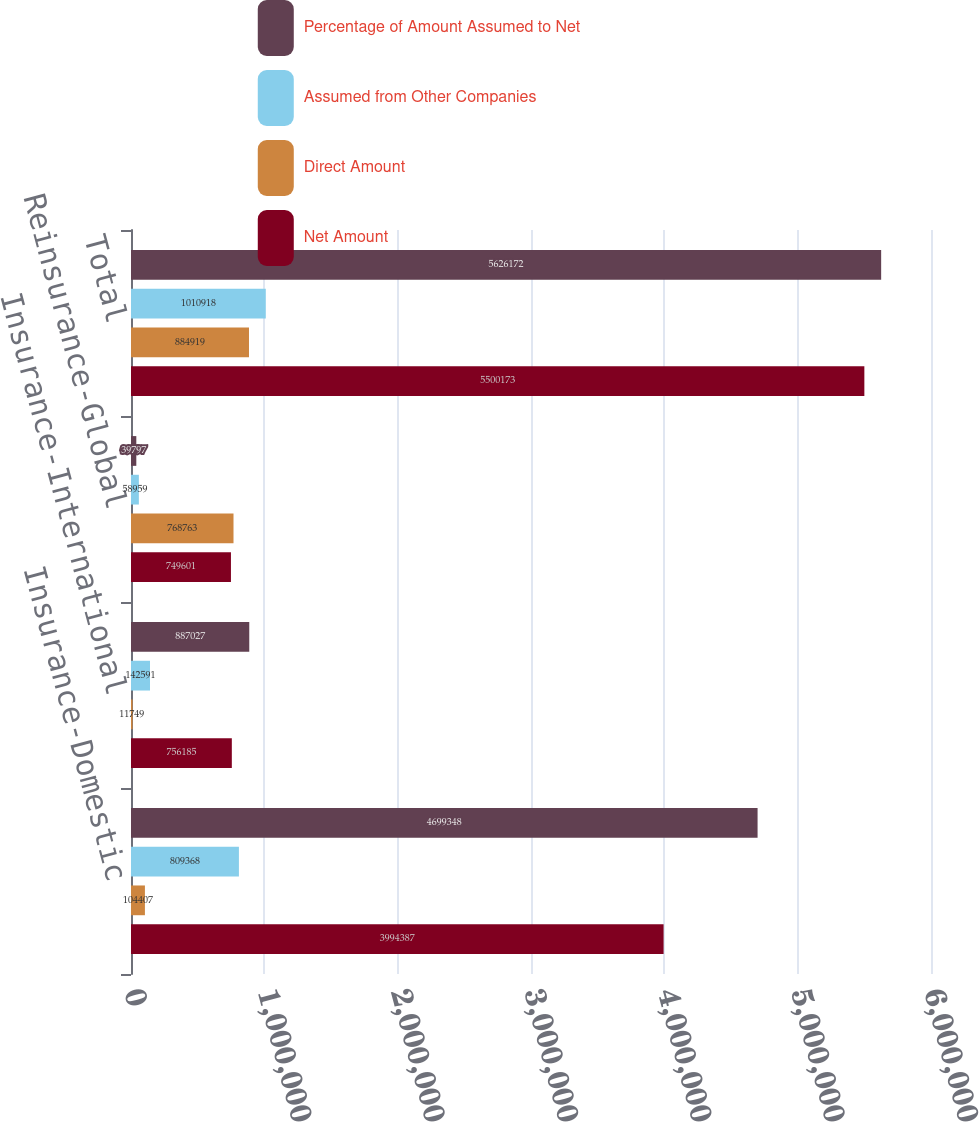<chart> <loc_0><loc_0><loc_500><loc_500><stacked_bar_chart><ecel><fcel>Insurance-Domestic<fcel>Insurance-International<fcel>Reinsurance-Global<fcel>Total<nl><fcel>Percentage of Amount Assumed to Net<fcel>4.69935e+06<fcel>887027<fcel>39797<fcel>5.62617e+06<nl><fcel>Assumed from Other Companies<fcel>809368<fcel>142591<fcel>58959<fcel>1.01092e+06<nl><fcel>Direct Amount<fcel>104407<fcel>11749<fcel>768763<fcel>884919<nl><fcel>Net Amount<fcel>3.99439e+06<fcel>756185<fcel>749601<fcel>5.50017e+06<nl></chart> 